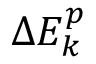Convert formula to latex. <formula><loc_0><loc_0><loc_500><loc_500>\Delta E _ { k } ^ { p }</formula> 